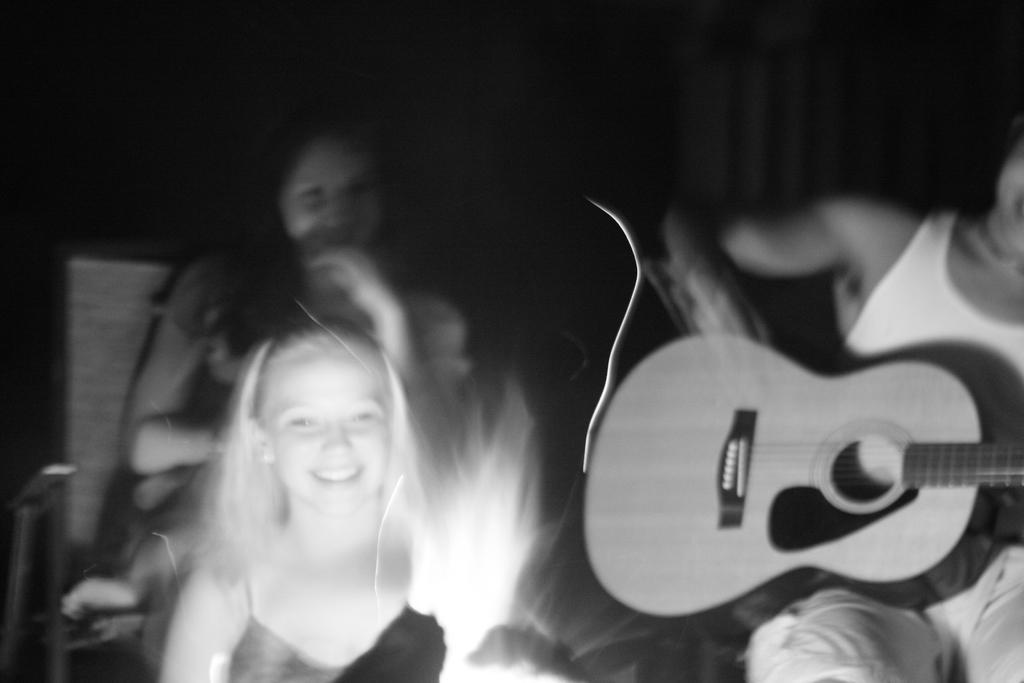In one or two sentences, can you explain what this image depicts? In this image i can see few persons sitting and to the right of the image i can see a person sitting on a chair and holding a guitar, and i can see a dark background. 